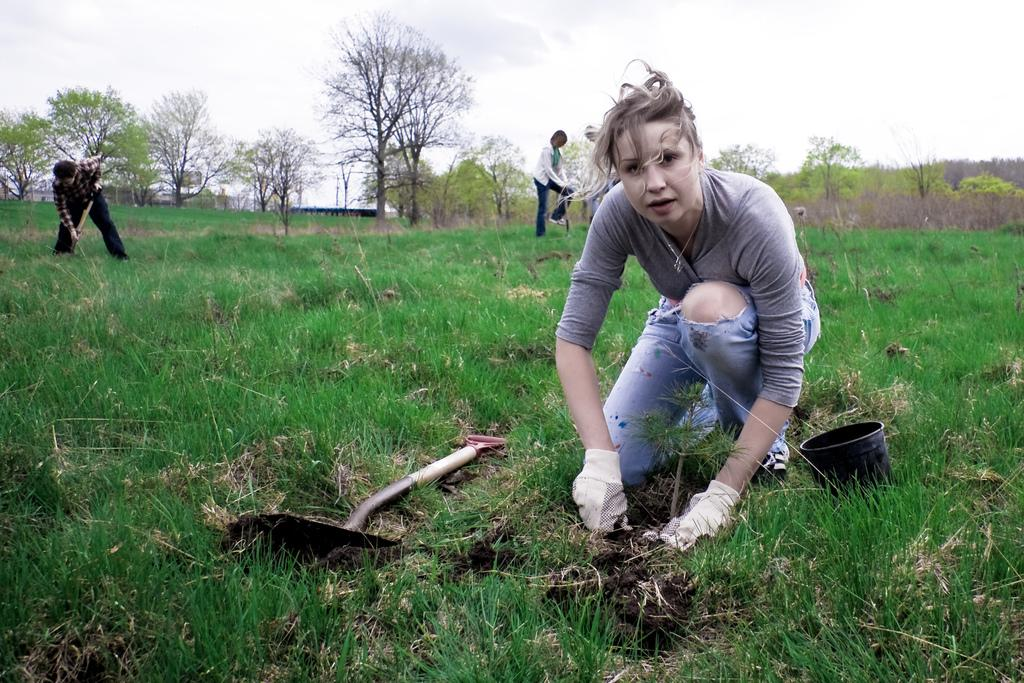What type of surface is visible in the image? There is ground visible in the image. What is located on the ground? There are objects on the ground. What type of vegetation can be seen in the image? There is grass in the image. What else can be seen in the image besides the ground and grass? There are trees in the image. What is visible in the background of the image? The sky is visible in the image, and clouds are present in the sky. Are there any living beings in the image? Yes, there are people in the image. What is the name of the fireman in the image? There is no fireman present in the image. What time of day is it in the image, given the presence of night? The image does not depict nighttime; the sky is visible with clouds, indicating daytime. 